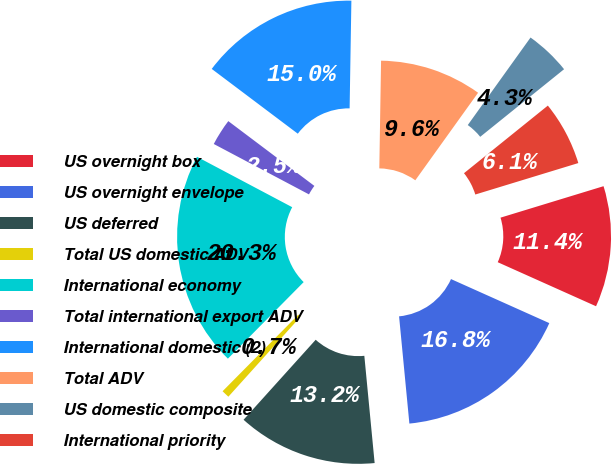<chart> <loc_0><loc_0><loc_500><loc_500><pie_chart><fcel>US overnight box<fcel>US overnight envelope<fcel>US deferred<fcel>Total US domestic ADV<fcel>International economy<fcel>Total international export ADV<fcel>International domestic (2)<fcel>Total ADV<fcel>US domestic composite<fcel>International priority<nl><fcel>11.42%<fcel>16.77%<fcel>13.2%<fcel>0.74%<fcel>20.33%<fcel>2.52%<fcel>14.99%<fcel>9.64%<fcel>4.3%<fcel>6.08%<nl></chart> 